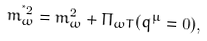Convert formula to latex. <formula><loc_0><loc_0><loc_500><loc_500>m _ { \omega } ^ { ^ { * } 2 } = m _ { \omega } ^ { 2 } + \Pi _ { \omega T } ( q ^ { \mu } = 0 ) ,</formula> 